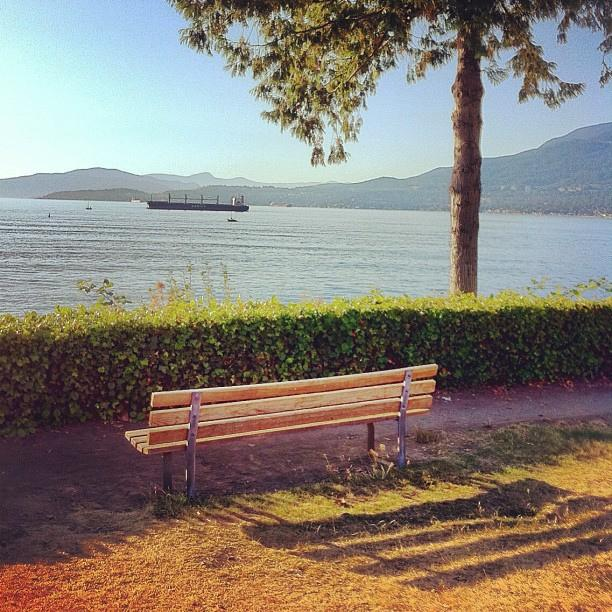What is casted on the ground behind the bench? shadow 